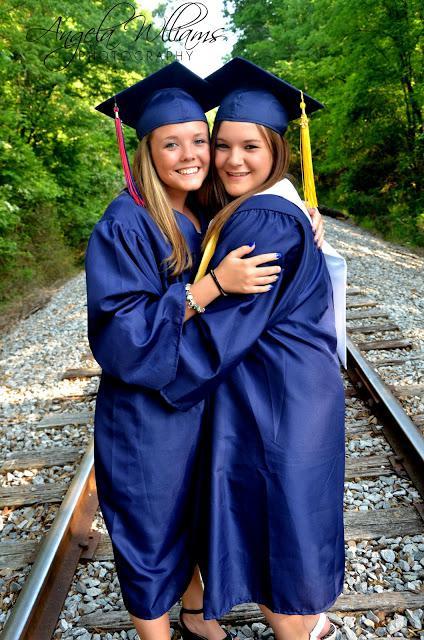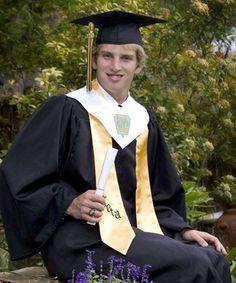The first image is the image on the left, the second image is the image on the right. Assess this claim about the two images: "The left image contains exactly two people wearing graduation uniforms.". Correct or not? Answer yes or no. Yes. The first image is the image on the left, the second image is the image on the right. Evaluate the accuracy of this statement regarding the images: "One picture has atleast 2 women in it.". Is it true? Answer yes or no. Yes. 